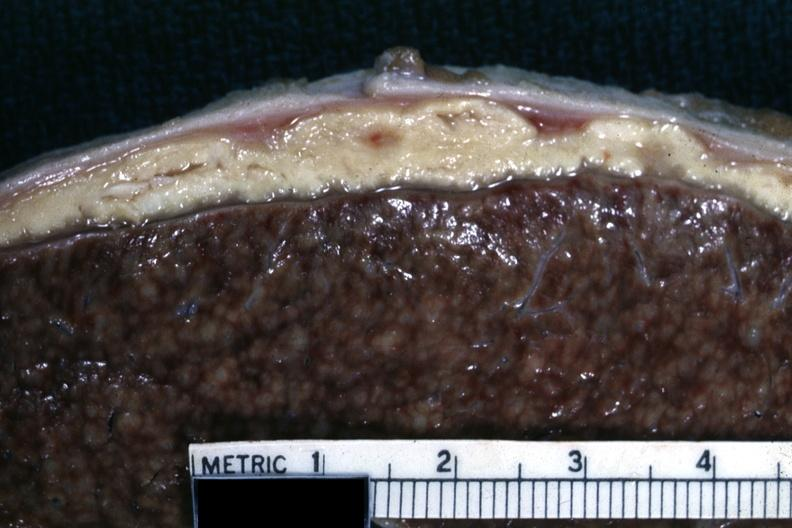s abdomen present?
Answer the question using a single word or phrase. Yes 